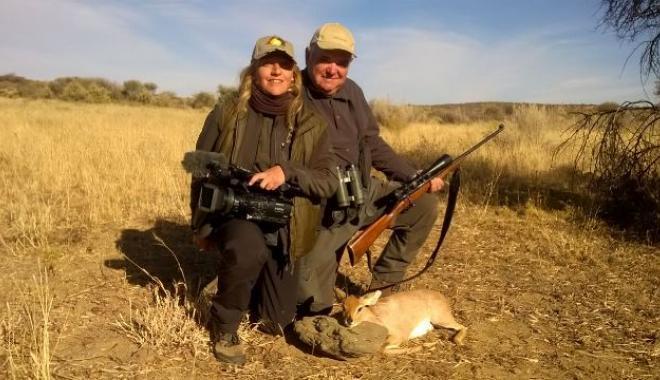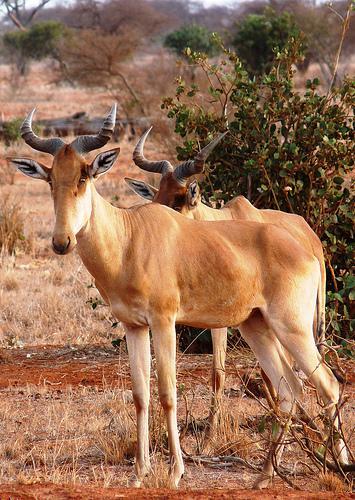The first image is the image on the left, the second image is the image on the right. Considering the images on both sides, is "Each image contains multiple horned animals, and one image includes horned animals facing opposite directions and overlapping." valid? Answer yes or no. No. The first image is the image on the left, the second image is the image on the right. Evaluate the accuracy of this statement regarding the images: "There are exactly two living animals.". Is it true? Answer yes or no. Yes. 